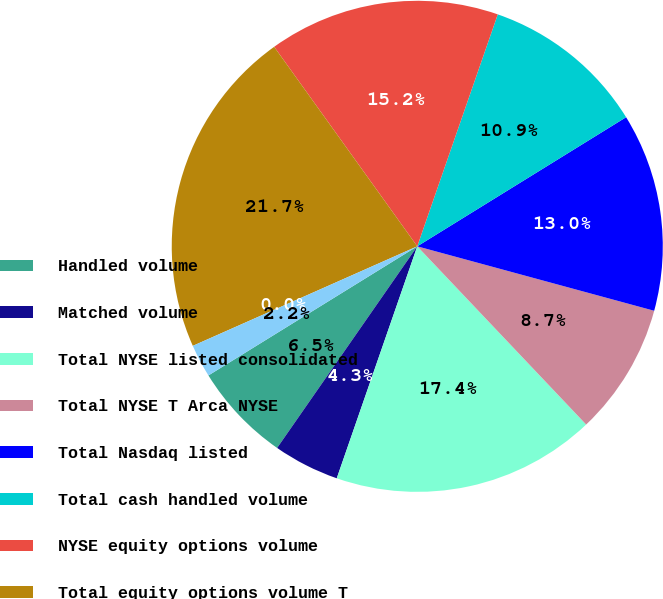<chart> <loc_0><loc_0><loc_500><loc_500><pie_chart><fcel>Handled volume<fcel>Matched volume<fcel>Total NYSE listed consolidated<fcel>Total NYSE T Arca NYSE<fcel>Total Nasdaq listed<fcel>Total cash handled volume<fcel>NYSE equity options volume<fcel>Total equity options volume T<fcel>Cash equities rate per<fcel>Equity options rate per<nl><fcel>6.52%<fcel>4.35%<fcel>17.39%<fcel>8.7%<fcel>13.04%<fcel>10.87%<fcel>15.22%<fcel>21.74%<fcel>0.0%<fcel>2.17%<nl></chart> 